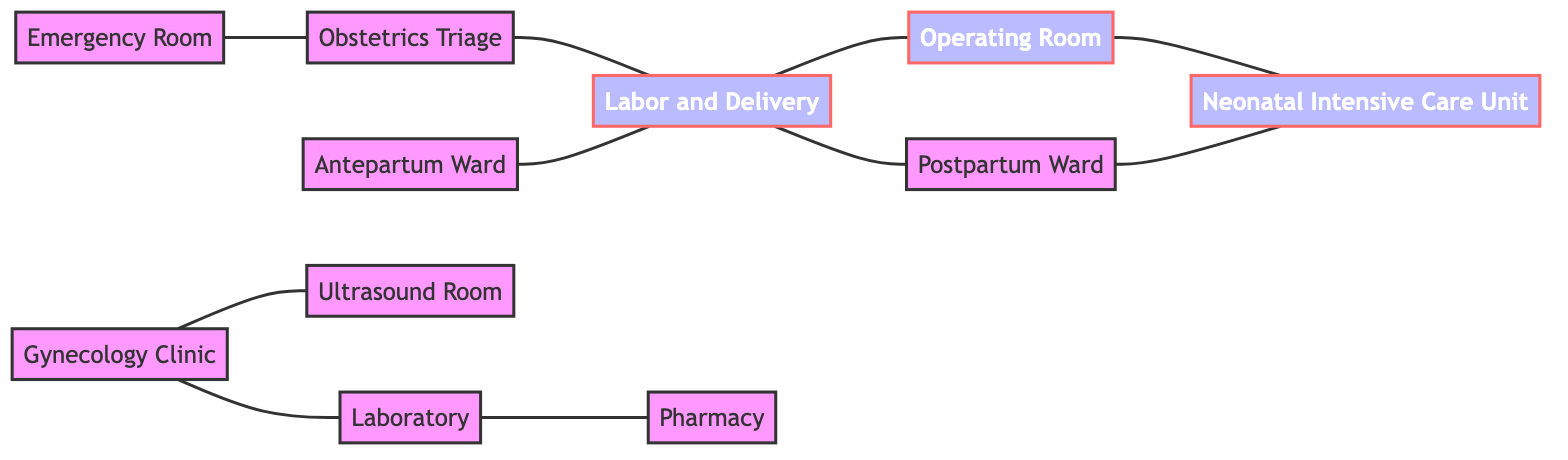What are the total number of nodes in the diagram? The diagram includes 11 nodes, each representing a specific unit within the Obstetrics and Gynecology Department. These nodes are distinct entities that include the Emergency Room, Obstetrics Triage, Labor and Delivery, Antepartum Ward, Postpartum Ward, Operating Room, Neonatal Intensive Care Unit, Gynecology Clinic, Ultrasound Room, Laboratory, and Pharmacy.
Answer: 11 Which unit connects directly to the Operating Room? The Operating Room connects directly to the Labor and Delivery and the Neonatal Intensive Care Unit. The relationship can be identified by the edges in the diagram, showing that the Operating Room serves as a conduit between these units.
Answer: Labor and Delivery, Neonatal Intensive Care Unit How many units are directly connected to the Labor and Delivery? The Labor and Delivery node connects directly to four other units: Obstetrics Triage, Postpartum Ward, Antepartum Ward, and the Operating Room, indicating a central role in patient flow within the department.
Answer: 4 Which nodes are connected to the Gynecology Clinic? The Gynecology Clinic is directly connected to two units: the Ultrasound Room and the Laboratory, indicating the pathways for patient referrals or multi-disciplinary care within gynecology.
Answer: Ultrasound Room, Laboratory What is the path from the Emergency Room to the Neonatal Intensive Care Unit? Starting from the Emergency Room, the path to the Neonatal Intensive Care Unit goes through the Obstetrics Triage, then to Labor and Delivery, and finally to the Operating Room. This sequential connection underscores the flow of patients from emergency assessment to surgical support and then to neonatal care.
Answer: Emergency Room -> Obstetrics Triage -> Labor and Delivery -> Operating Room -> Neonatal Intensive Care Unit Which unit has the most direct connections? The Labor and Delivery node features the most direct connections to several other units: it links to Obstetrics Triage, Postpartum Ward, Antepartum Ward, and Operating Room, resulting in a total of four direct connections, making it central to the patient flow within the diagram.
Answer: Labor and Delivery Is there any unit that has no outgoing connections? The diagram shows that all units have at least one outgoing connection except for the Postpartum Ward, which connects solely to the Neonatal Intensive Care Unit, implying it mainly serves patients after delivery before transfer to NICU care.
Answer: No How many connections lead to the Neonatal Intensive Care Unit? The Neonatal Intensive Care Unit is connected by three different units: Operating Room, Postpartum Ward, and Labor and Delivery, indicating it receives patients from multiple points following childbirth or surgical procedures.
Answer: 3 Which two units have a direct connection for diagnostic purposes? The Laboratory and Pharmacy have a direct connection, highlighting the pathway for diagnostic tests and the provision of medications, essential for patient care in obstetrics and gynecology.
Answer: Laboratory, Pharmacy 